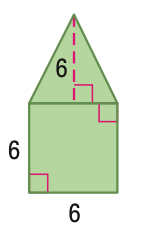Answer the mathemtical geometry problem and directly provide the correct option letter.
Question: Find the perimeter of the figure. Round to the nearest tenth if necessary.
Choices: A: 24.0 B: 24.7 C: 25.4 D: 31.4 D 